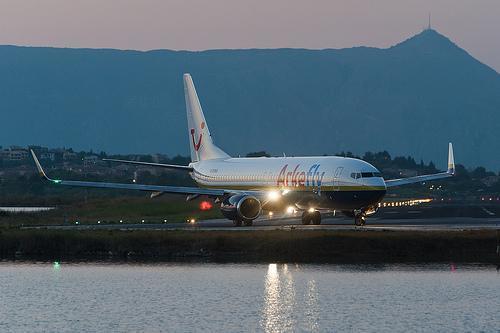How many doors on the plane are visible?
Give a very brief answer. 1. 